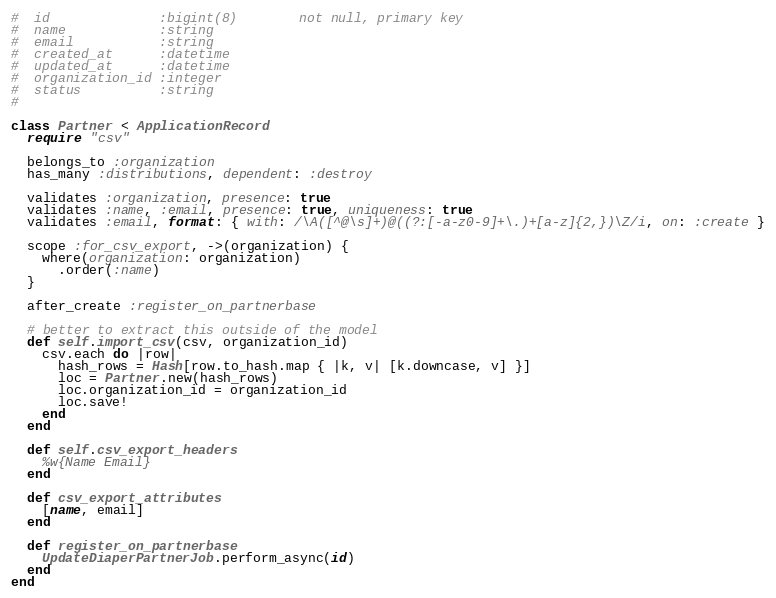<code> <loc_0><loc_0><loc_500><loc_500><_Ruby_>#  id              :bigint(8)        not null, primary key
#  name            :string
#  email           :string
#  created_at      :datetime
#  updated_at      :datetime
#  organization_id :integer
#  status          :string
#

class Partner < ApplicationRecord
  require "csv"

  belongs_to :organization
  has_many :distributions, dependent: :destroy

  validates :organization, presence: true
  validates :name, :email, presence: true, uniqueness: true
  validates :email, format: { with: /\A([^@\s]+)@((?:[-a-z0-9]+\.)+[a-z]{2,})\Z/i, on: :create }

  scope :for_csv_export, ->(organization) {
    where(organization: organization)
      .order(:name)
  }

  after_create :register_on_partnerbase

  # better to extract this outside of the model
  def self.import_csv(csv, organization_id)
    csv.each do |row|
      hash_rows = Hash[row.to_hash.map { |k, v| [k.downcase, v] }]
      loc = Partner.new(hash_rows)
      loc.organization_id = organization_id
      loc.save!
    end
  end

  def self.csv_export_headers
    %w{Name Email}
  end

  def csv_export_attributes
    [name, email]
  end

  def register_on_partnerbase
    UpdateDiaperPartnerJob.perform_async(id)
  end
end
</code> 